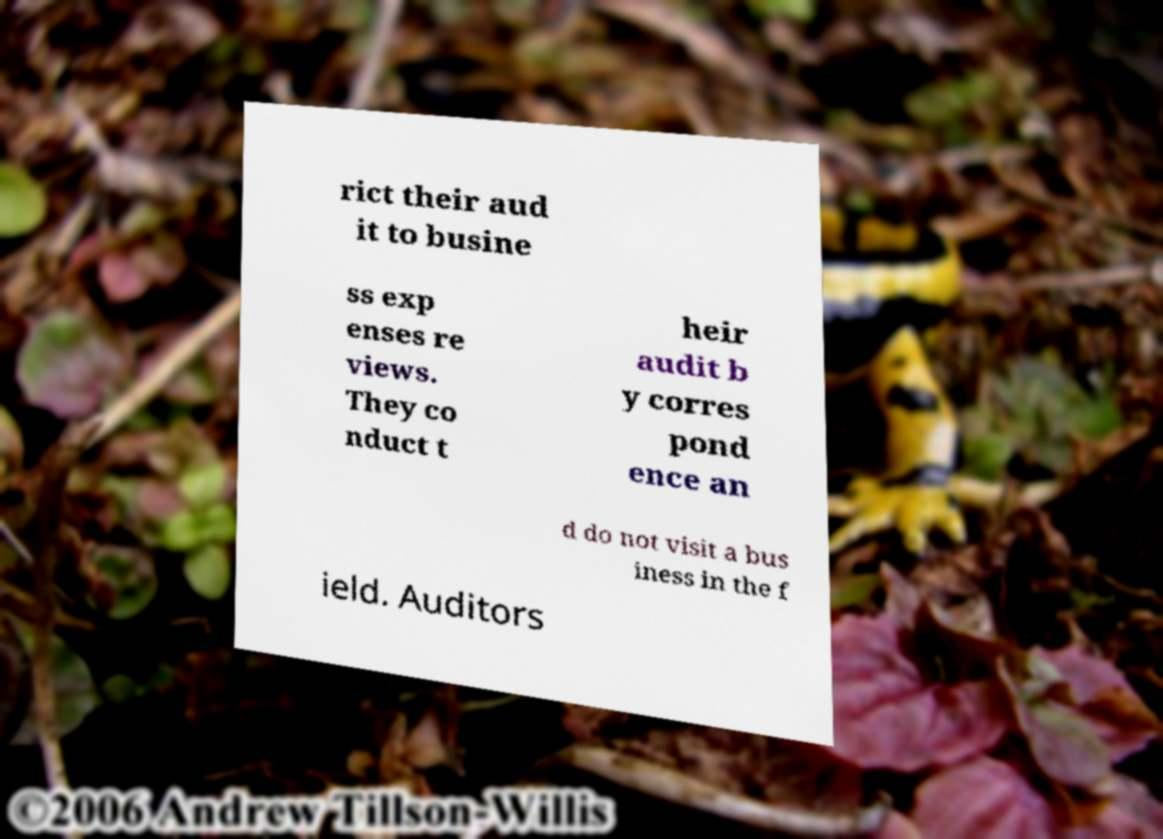What messages or text are displayed in this image? I need them in a readable, typed format. rict their aud it to busine ss exp enses re views. They co nduct t heir audit b y corres pond ence an d do not visit a bus iness in the f ield. Auditors 